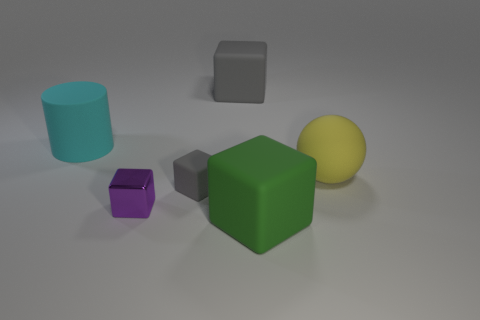Can you tell me which objects are visible in this image and their colors? Certainly! The image depicts six distinct objects on a neutral background. From left to right, we see a cyan cylinder, a small purple cube, a green cube with a larger size, a small gray matte cube, a yellow sphere, and a large gray cube with a slightly reflective surface. 